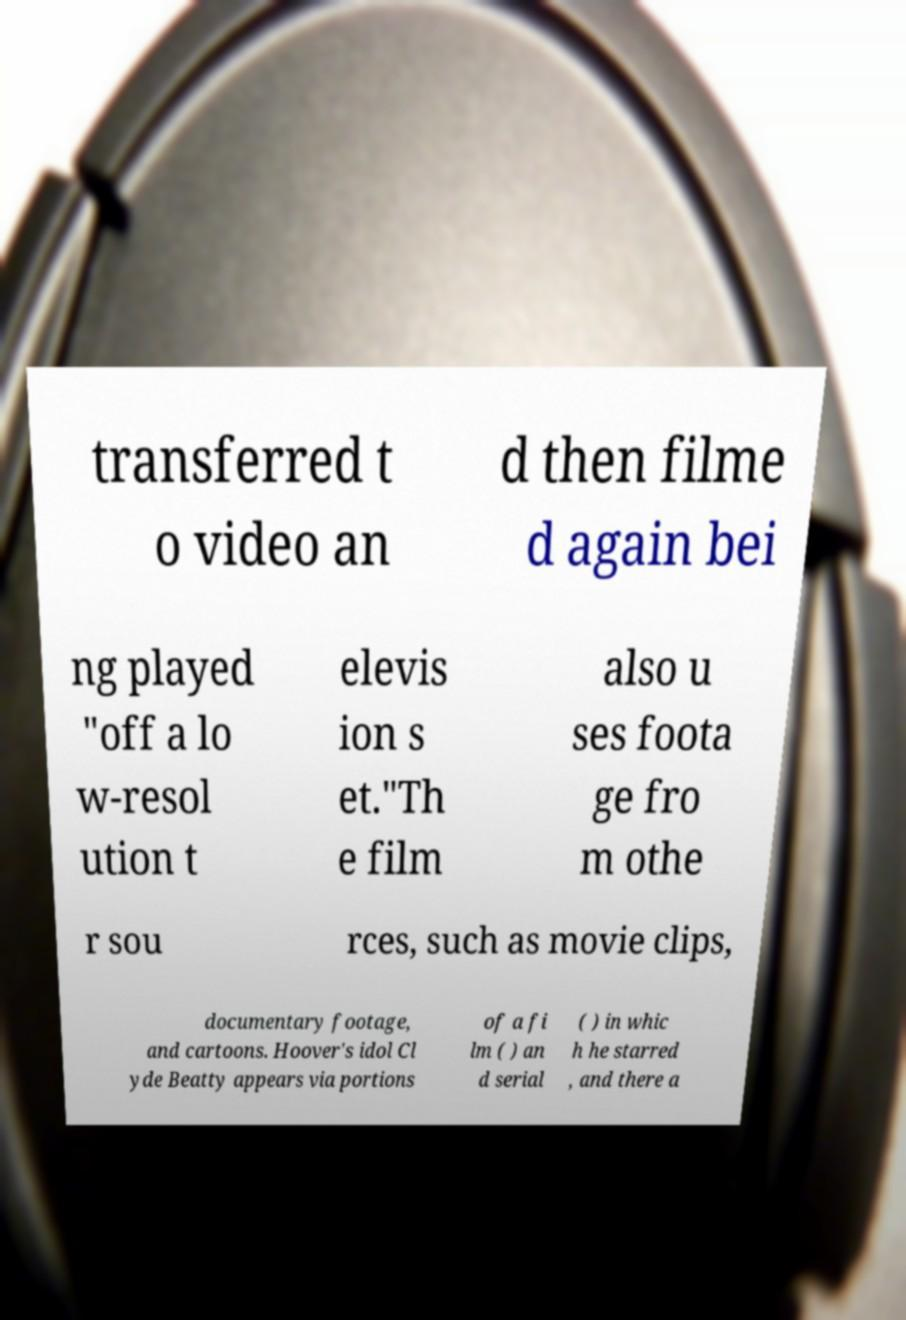What messages or text are displayed in this image? I need them in a readable, typed format. transferred t o video an d then filme d again bei ng played "off a lo w-resol ution t elevis ion s et."Th e film also u ses foota ge fro m othe r sou rces, such as movie clips, documentary footage, and cartoons. Hoover's idol Cl yde Beatty appears via portions of a fi lm ( ) an d serial ( ) in whic h he starred , and there a 